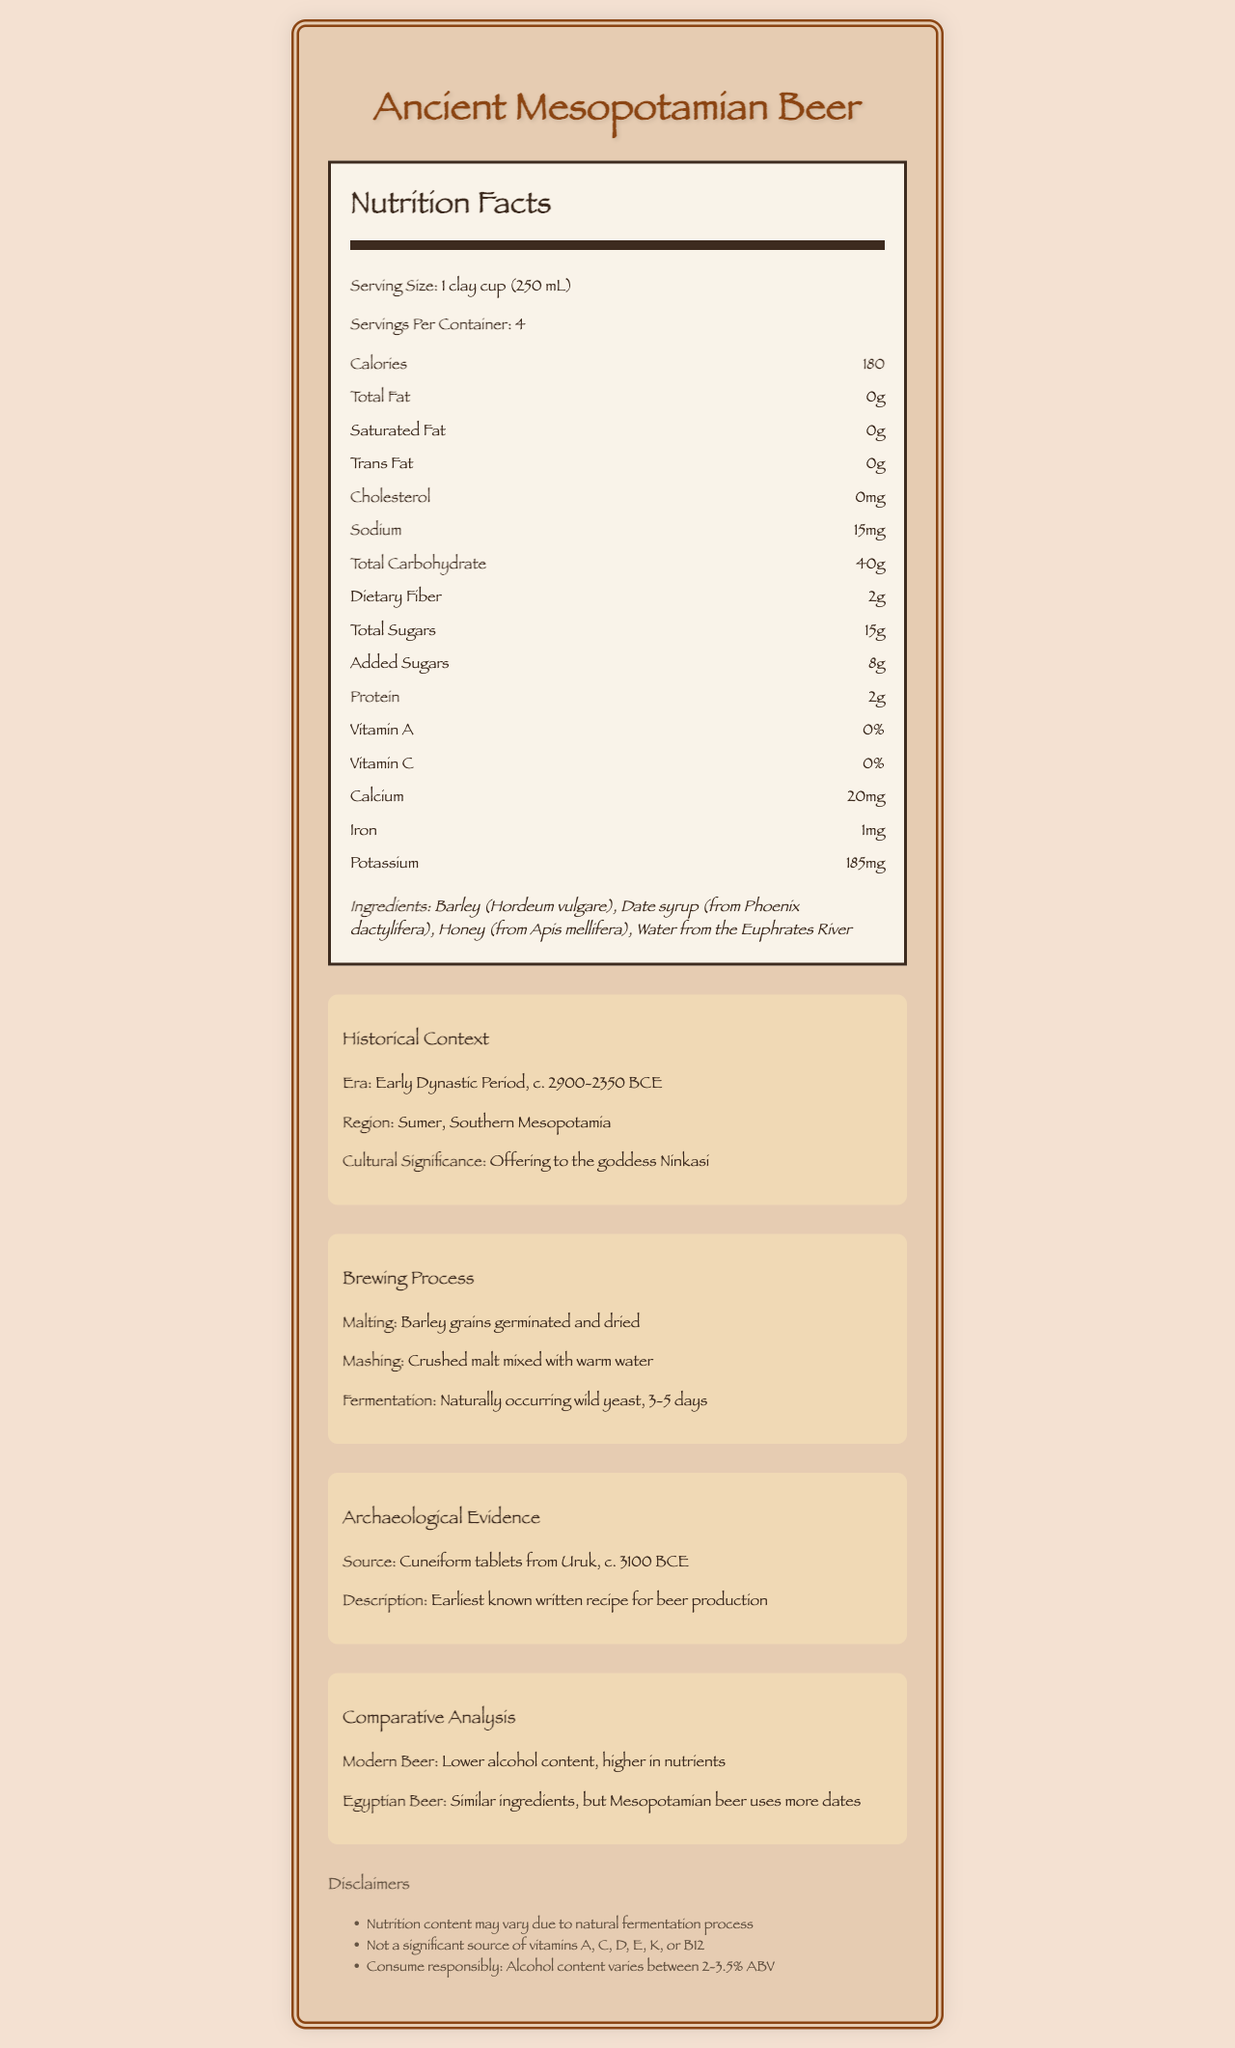what is the serving size? The serving size is specified as "1 clay cup (250 mL)" in the nutrition facts section.
Answer: 1 clay cup (250 mL) how many servings are in one container of Ancient Mesopotamian Beer? The document lists "Servings Per Container: 4" in the nutrition facts section.
Answer: 4 what is the calorie count per serving? The "Calories" section under the nutrition facts specifies 180 calories per serving.
Answer: 180 calories how much protein is there per serving? The nutrition facts indicate that each serving contains 2 grams of protein.
Answer: 2 grams list the primary ingredients of Ancient Mesopotamian Beer. These ingredients are listed under the "Ingredients" section.
Answer: Barley (Hordeum vulgare), Date syrup (from Phoenix dactylifera), Honey (from Apis mellifera), Water from the Euphrates River which period does the Ancient Mesopotamian Beer originate from? A. Middle Ages B. Roman Empire C. Early Dynastic Period The historical context section specifies the era as "Early Dynastic Period, c. 2900-2350 BCE".
Answer: C. Early Dynastic Period what is the main source of sweetness in the beer? A. Barley B. Honey C. Date syrup The ingredients list includes date syrup as a natural sweetener and is emphasized in the nutritional notes.
Answer: C. Date syrup does the beer contain any trans fat? The nutrition facts indicate that the beer has 0 grams of trans fat.
Answer: No is alcohol content specifically listed as a nutrient? The nutritional content section does not list alcohol content; it is mentioned in the disclaimer section.
Answer: No summarize the main idea of the document. The document comprehensively describes the Ancient Mesopotamian Beer, covering aspects from its nutritional values to its historical and cultural significance, brewing methods, and archaeological evidence.
Answer: The document details the nutritional facts, ingredients, historical context, brewing process, archaeological evidence, and comparative analysis of Ancient Mesopotamian Beer. It also includes disclaimers regarding the variability in nutrition content and a note on alcohol content. how does Mesopotamian beer compare to modern beer in alcohol content? The comparative analysis section notes that Mesopotamian beer has a lower alcohol content compared to modern beer.
Answer: Lower can you determine the exact date of the earliest known written recipe for beer? The document only mentions that the source of the archaeological evidence is cuneiform tablets from Uruk around 3100 BCE, but does not specify an exact date.
Answer: Not enough information what nutrient is provided in the highest quantity by the beer’s ingredients? The nutrition facts list the total carbohydrate content as 40 grams per serving, the highest of the listed nutrients.
Answer: Carbohydrates which modern-day country would the historical region of Sumer be located in? The document describes the region as "Southern Mesopotamia" but does not specify a modern-day country.
Answer: Not enough information 